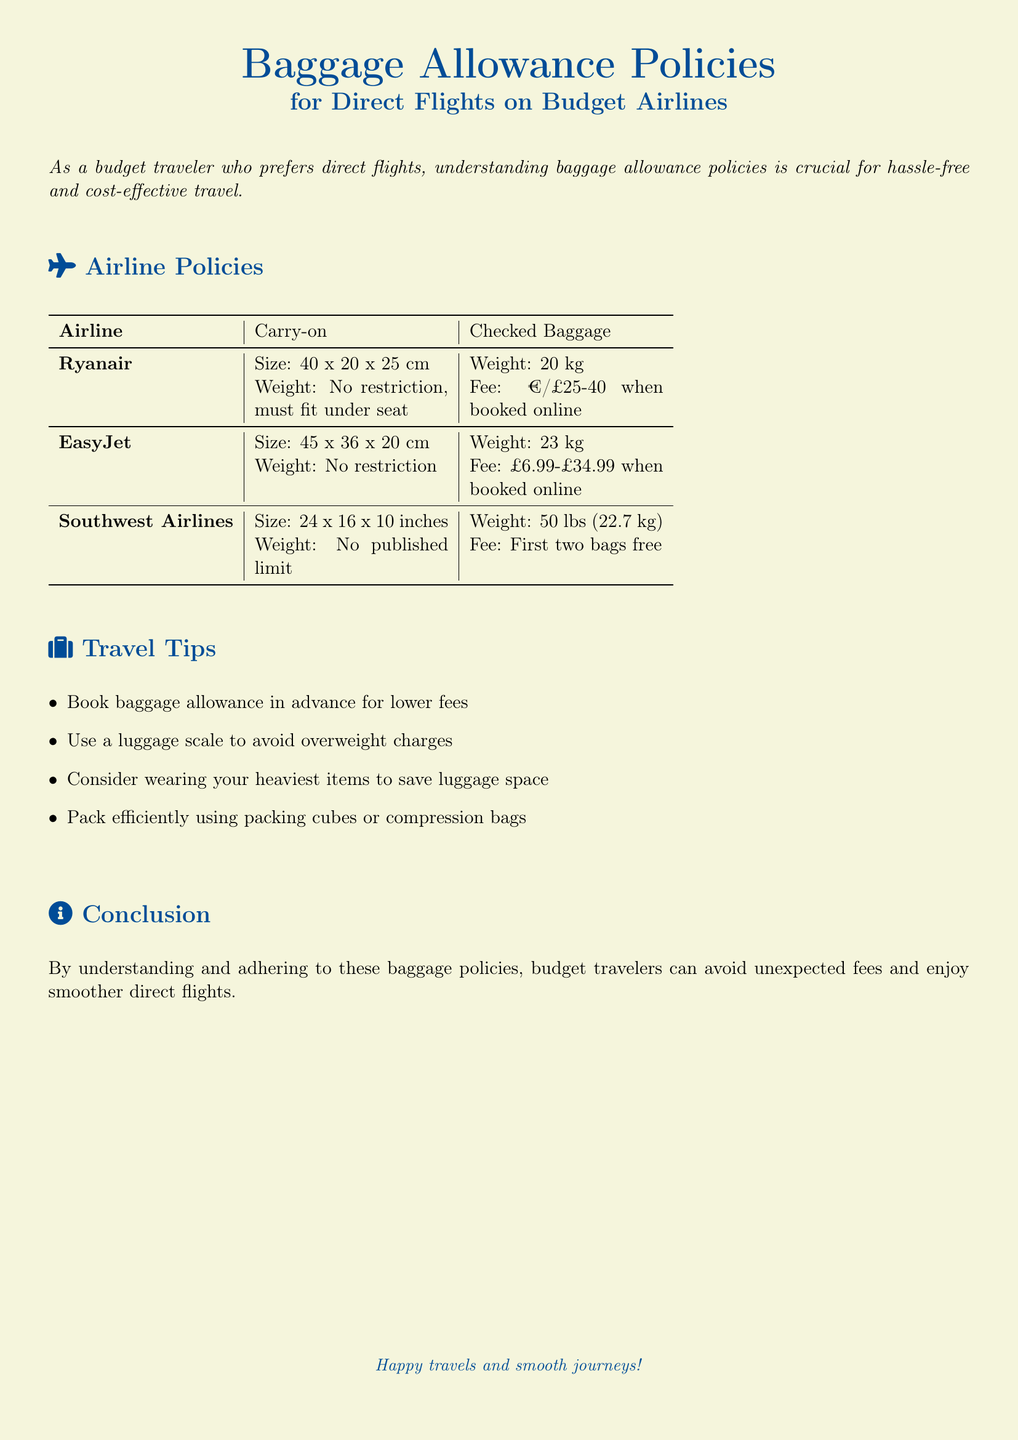What is the carry-on size limit for Ryanair? The carry-on size limit for Ryanair is specified in the table as 40 x 20 x 25 cm.
Answer: 40 x 20 x 25 cm What is the checked baggage weight limit for EasyJet? The checked baggage weight limit for EasyJet is stated in the document as 23 kg.
Answer: 23 kg Are there any weight restrictions for carry-on luggage on Southwest Airlines? The document mentions that there is no published weight limit for carry-on luggage on Southwest Airlines.
Answer: No published limit What is the checked baggage fee range for Ryanair when booked online? The fee range for Ryanair's checked baggage is provided as €/£25-40 when booked online.
Answer: €/£25-40 How many bags does Southwest Airlines allow for free? According to the document, Southwest Airlines allows the first two bags for free.
Answer: First two bags free What is the maximum carry-on size for EasyJet? The document specifies the maximum carry-on size for EasyJet as 45 x 36 x 20 cm.
Answer: 45 x 36 x 20 cm What is suggested to avoid overweight charges? The document recommends using a luggage scale to avoid overweight charges.
Answer: Use a luggage scale What is a recommended packing tool mentioned in the travel tips? The document suggests using packing cubes or compression bags.
Answer: Packing cubes or compression bags What is the carry-on weight restriction for Ryanair? The document states that Ryanair has no carry-on weight restriction as long as it fits under the seat.
Answer: No restriction, must fit under seat 